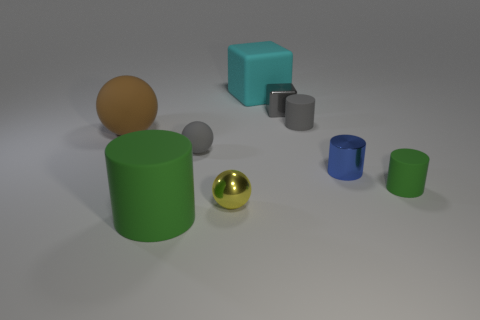Add 1 large gray matte things. How many objects exist? 10 Subtract all cylinders. How many objects are left? 5 Add 6 tiny red matte blocks. How many tiny red matte blocks exist? 6 Subtract 0 green blocks. How many objects are left? 9 Subtract all purple rubber cylinders. Subtract all tiny gray cylinders. How many objects are left? 8 Add 7 metallic objects. How many metallic objects are left? 10 